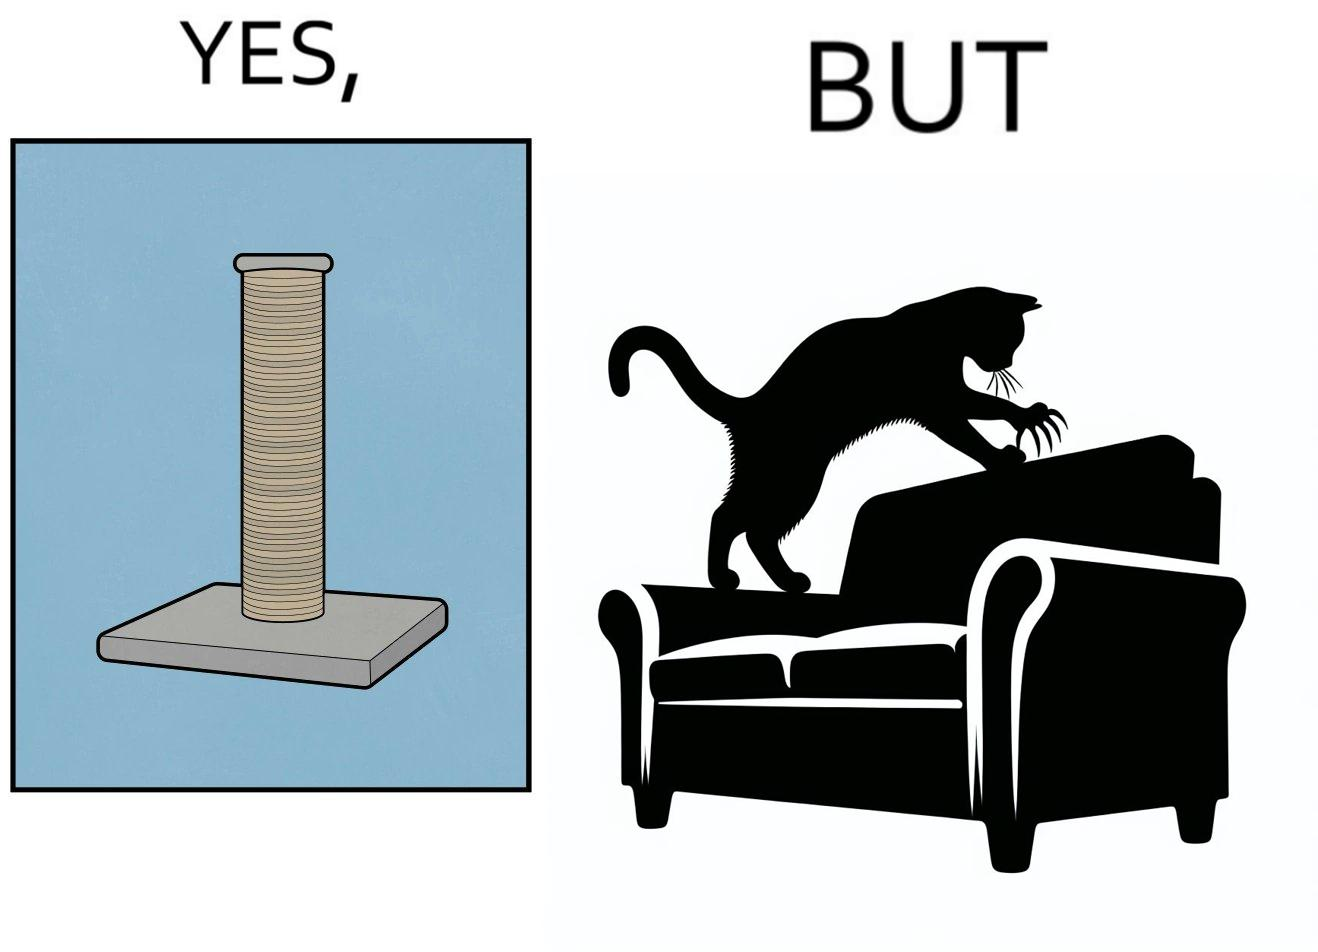What do you see in each half of this image? In the left part of the image: a cylindrical toy or some sort of thing  with a lots of rope wounded around its surface In the right part of the image: a cat scratching its nails over the sides of a sofa or trying to climb up the sofa 